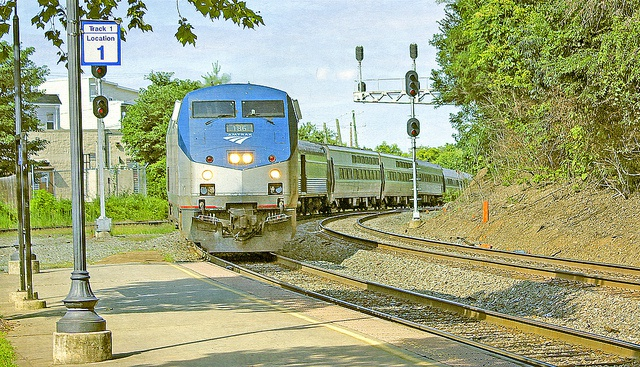Describe the objects in this image and their specific colors. I can see train in lightgray, darkgray, lightblue, and olive tones, traffic light in lightgray, gray, black, darkgreen, and teal tones, traffic light in lightgray, darkgreen, black, and gray tones, traffic light in lightgray, gray, white, black, and darkgreen tones, and traffic light in lightgray, black, and darkgreen tones in this image. 